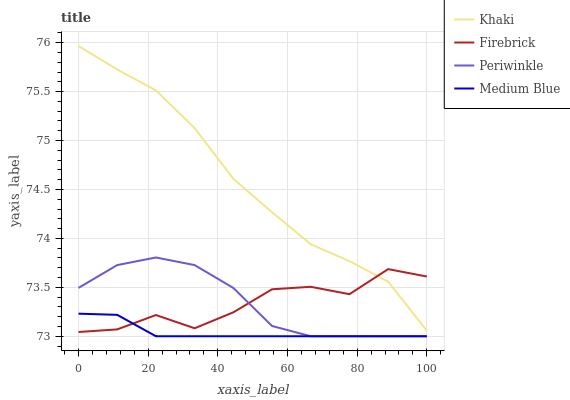Does Firebrick have the minimum area under the curve?
Answer yes or no. No. Does Firebrick have the maximum area under the curve?
Answer yes or no. No. Is Khaki the smoothest?
Answer yes or no. No. Is Khaki the roughest?
Answer yes or no. No. Does Firebrick have the lowest value?
Answer yes or no. No. Does Firebrick have the highest value?
Answer yes or no. No. Is Medium Blue less than Khaki?
Answer yes or no. Yes. Is Khaki greater than Periwinkle?
Answer yes or no. Yes. Does Medium Blue intersect Khaki?
Answer yes or no. No. 